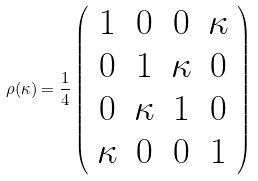<formula> <loc_0><loc_0><loc_500><loc_500>\rho ( \kappa ) = \frac { 1 } { 4 } \left ( \begin{array} { c c c c } 1 & 0 & 0 & \kappa \\ 0 & 1 & \kappa & 0 \\ 0 & \kappa & 1 & 0 \\ \kappa & 0 & 0 & 1 \end{array} \right )</formula> 